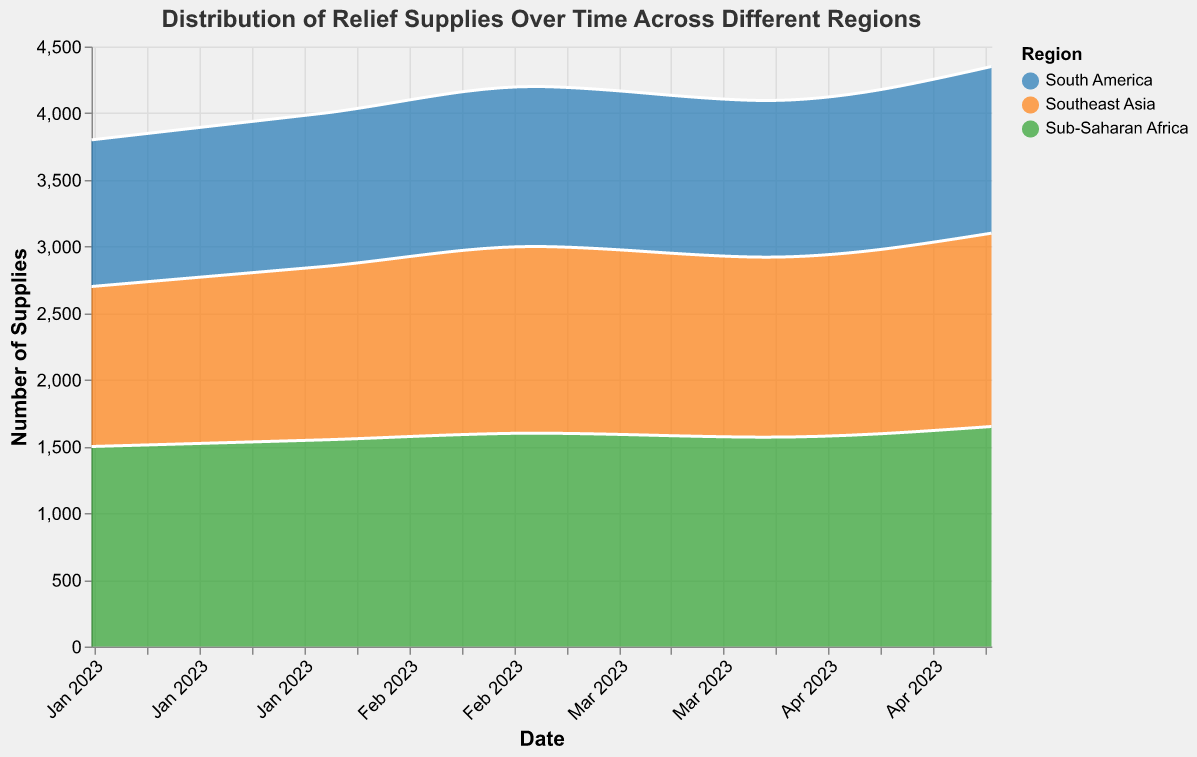What is the title of the chart? The title is located at the top of the chart and provides a brief description of the chart's content.
Answer: Distribution of Relief Supplies Over Time Across Different Regions Which month shows the highest amount of food supplies delivered to Sub-Saharan Africa? The chart shows that the food supplies for Sub-Saharan Africa are represented by the color corresponding to this region. By comparing the area heights for each month, the highest value for food supplies is in May 2023.
Answer: May 2023 Which region received the least amount of medical supplies in January 2023? The color-coded regions in the chart indicate their respective supplies. Looking at the data for January 2023, South America is shown to have the lowest area height for medical supplies compared to the other regions.
Answer: South America How did food supplies to Southeast Asia change from January 2023 to May 2023? Observing the area size for food supplies to Southeast Asia over the months, it gradually increases from January 2023 (1200 supplies) to May 2023 (1450 supplies).
Answer: They increased What is the trend of water supplies in Sub-Saharan Africa over the given time period? Examining the area representing water supplies for Sub-Saharan Africa, the trend shows a steady increase from January (1200) to May 2023 (1350).
Answer: Increasing Which region consistently received more food supplies than others across the months? To find this, compare the total height of the areas representing food supplies for each region over the months. Sub-Saharan Africa consistently stands out with the highest values each month.
Answer: Sub-Saharan Africa What was the approximate difference in shelter supplies between South America and Southeast Asia in April 2023? The shelter supplies for April 2023 for both regions must be compared. South America had 525 and Southeast Asia had 580, so the difference is 580 - 525.
Answer: 55 supplies What is the overall trend for medical supplies in Southeast Asia from January to May 2023? By closely observing the area sizes related to medical supplies for Southeast Asia, there is a consistent upward trend from January (800) to May 2023 (930).
Answer: Upward trend How did the water supplies to South America change from February to March 2023? The water supply levels for South America in February were 850, and in March, they were 900. Thus, there is an observed increase.
Answer: They increased In which month did Southeast Asia receive the highest amount of water supplies, and what was the amount? Comparing the heights of the areas for each month regarding water supplies to Southeast Asia, May 2023 shows the highest value which is 1020.
Answer: May 2023, 1020 supplies 